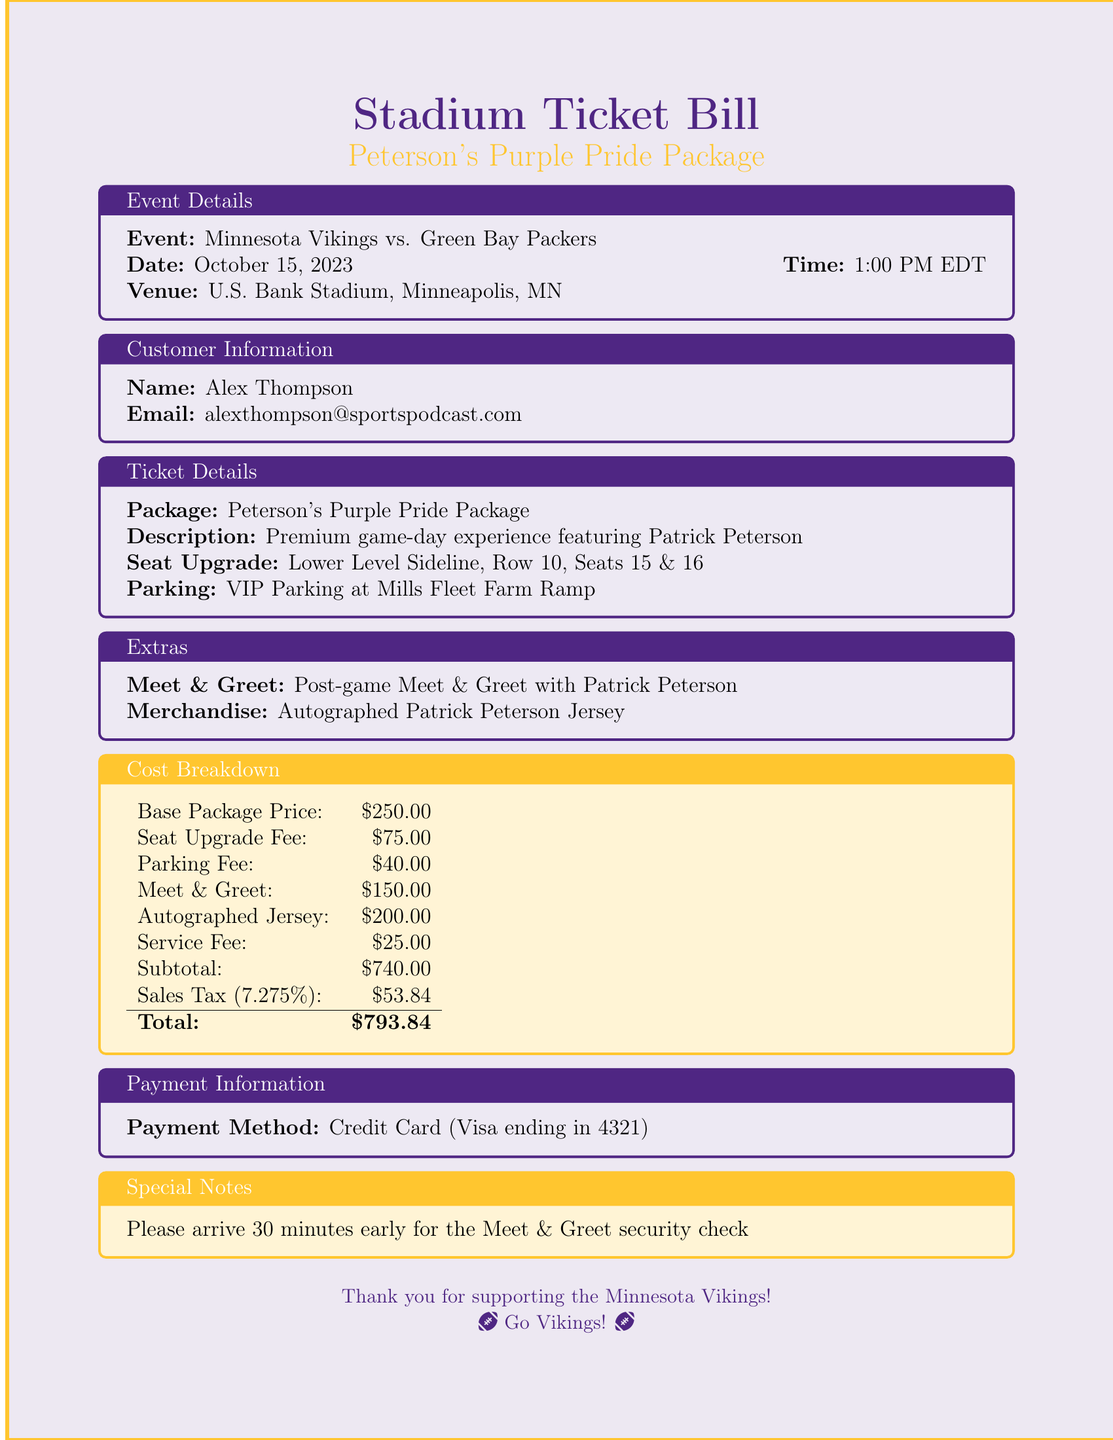What is the event featured in the document? The event is specifically listed in the document as the matchup between the Minnesota Vikings and the Green Bay Packers.
Answer: Minnesota Vikings vs. Green Bay Packers What is the date of the game? The date of the game is noted in the event details section of the document.
Answer: October 15, 2023 What is the seat upgrade fee? The fee for upgrading the seat is provided in the cost breakdown section of the document.
Answer: $75.00 Who is the featured player for the premium package? The featured player is mentioned in the description of the ticket package.
Answer: Patrick Peterson What is the total cost of the package? The total cost is clearly computed in the cost breakdown section at the end of the document.
Answer: $793.84 What type of parking is included in the package? The type of parking is detailed in the ticket details section of the document.
Answer: VIP Parking What merchandise is included with the purchase? The specific item of merchandise included is listed in the extras section of the document.
Answer: Autographed Patrick Peterson Jersey What is the service fee for the package? The service fee is highlighted in the cost breakdown section of the document.
Answer: $25.00 What time should customers arrive for the Meet & Greet? Arrival time for the Meet & Greet is specified in the special notes section of the document.
Answer: 30 minutes early 